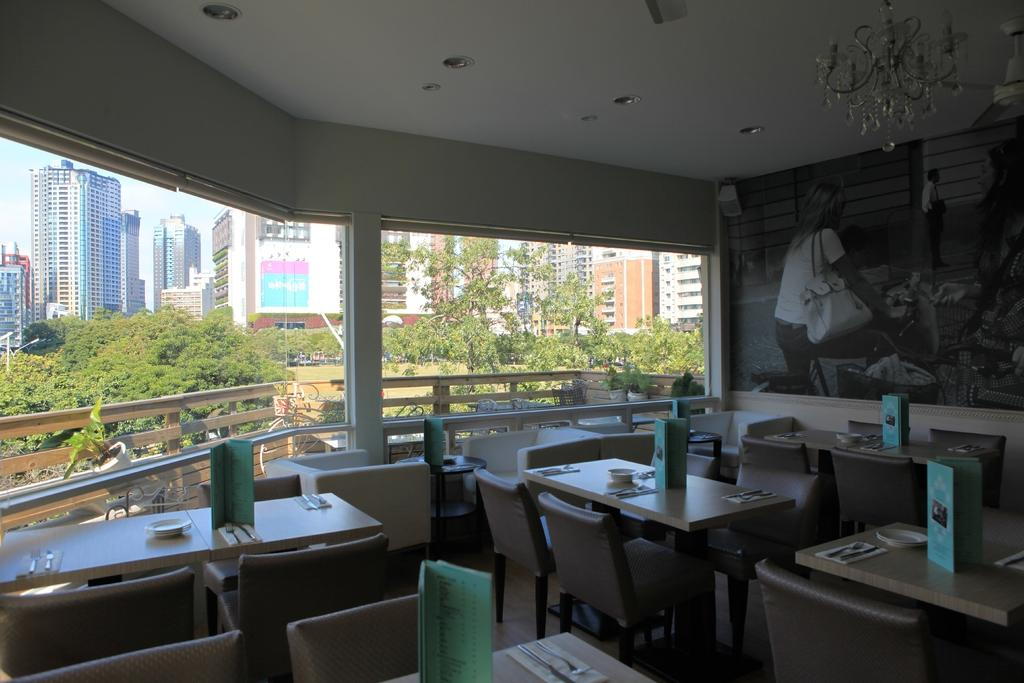What type of structures can be seen in the image? There are buildings in the image. What natural elements are present in the image? There are trees in the image. What type of barrier can be seen in the image? There is fencing in the image. What type of illumination is present in the image? There are lights in the image. What type of furniture is present in the image? There are chairs and tables in the image. What is visible in the sky in the image? The sky is visible in the image. What type of utensils are visible in the image? There are spoons visible in the image. What type of dishware is visible in the image? There are plates visible in the image. What objects can be seen on the tables in the image? There are objects on the tables in the image. How many mittens are being tested on the arm in the image? There are no mittens or arms present in the image. What type of arm is holding the test mitten in the image? There is no test mitten or arm present in the image. 